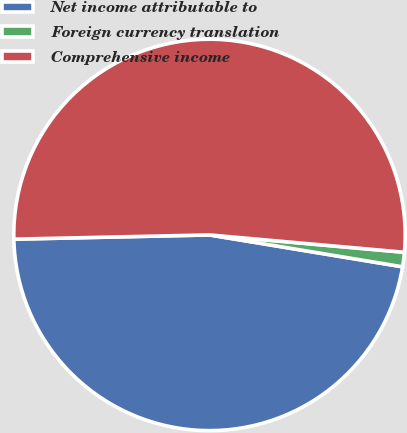Convert chart to OTSL. <chart><loc_0><loc_0><loc_500><loc_500><pie_chart><fcel>Net income attributable to<fcel>Foreign currency translation<fcel>Comprehensive income<nl><fcel>47.05%<fcel>1.19%<fcel>51.76%<nl></chart> 